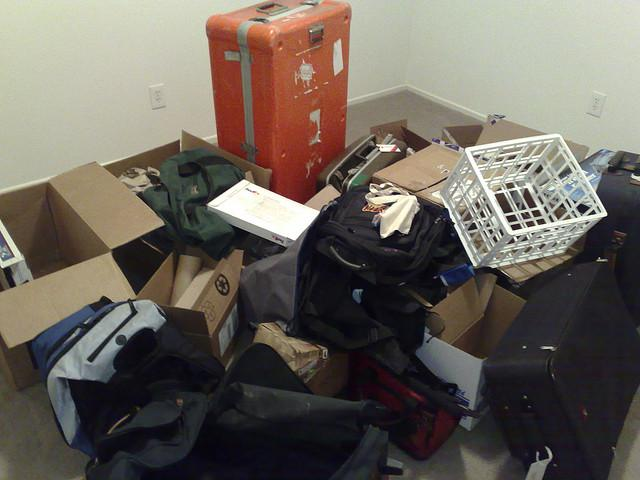What is someone who collects huge amounts of rubbish called?

Choices:
A) hoarder
B) butler
C) collector
D) miscreant hoarder 